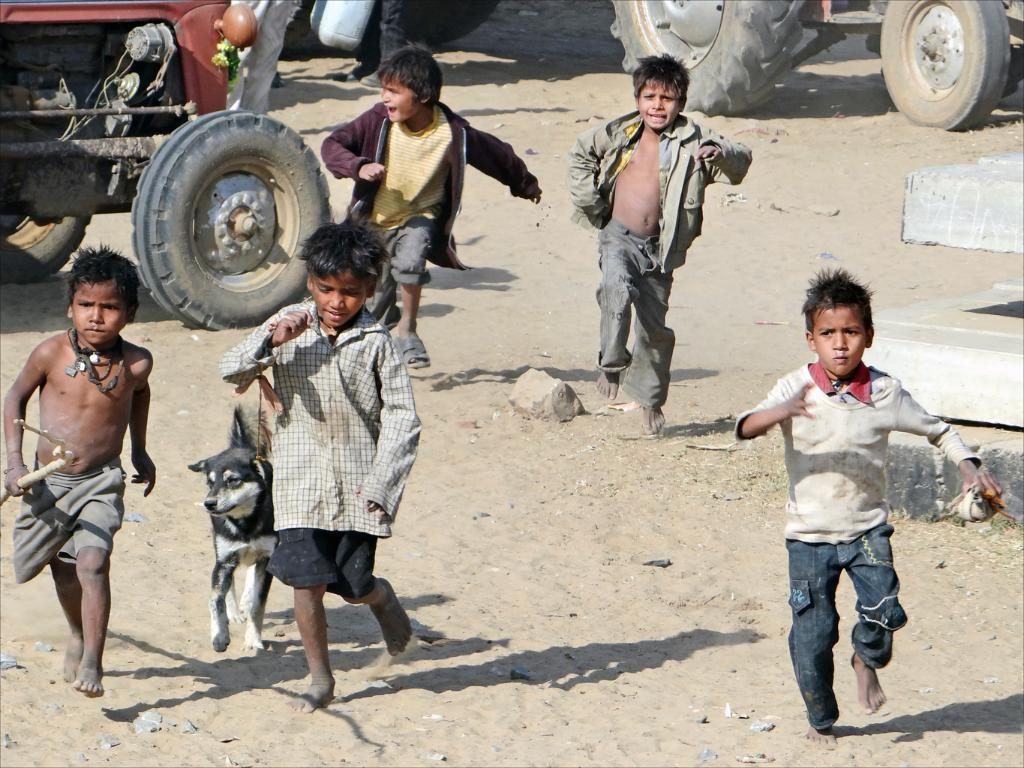What are the boys in the image doing? The boys in the image are running. What other animal is present in the image besides the boys? There is a dog in the image. What else can be seen in the image besides the boys and the dog? There are vehicles and stones on the ground in the image. Are there any other objects in the image that are not specified? Yes, there are some unspecified objects in the image. What is the chance of an earthquake happening in the image? There is no indication of an earthquake in the image, so it is not possible to determine the chance of one occurring. 